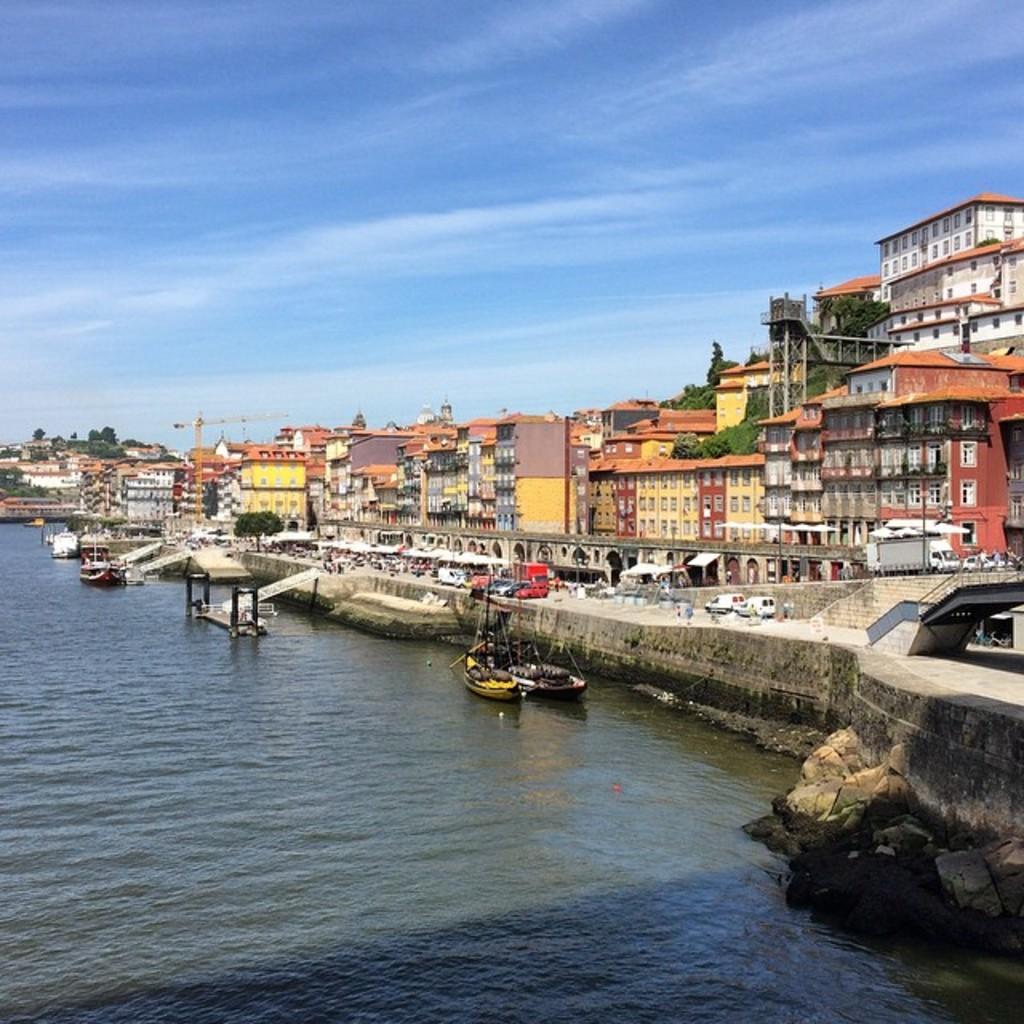Could you give a brief overview of what you see in this image? In this picture we can see there are boats on the water. On the right side of the boats there are vehicles, buildings, trees, a crane and the sky. 